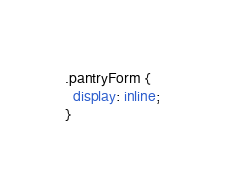Convert code to text. <code><loc_0><loc_0><loc_500><loc_500><_CSS_>
.pantryForm {
  display: inline;
}
</code> 